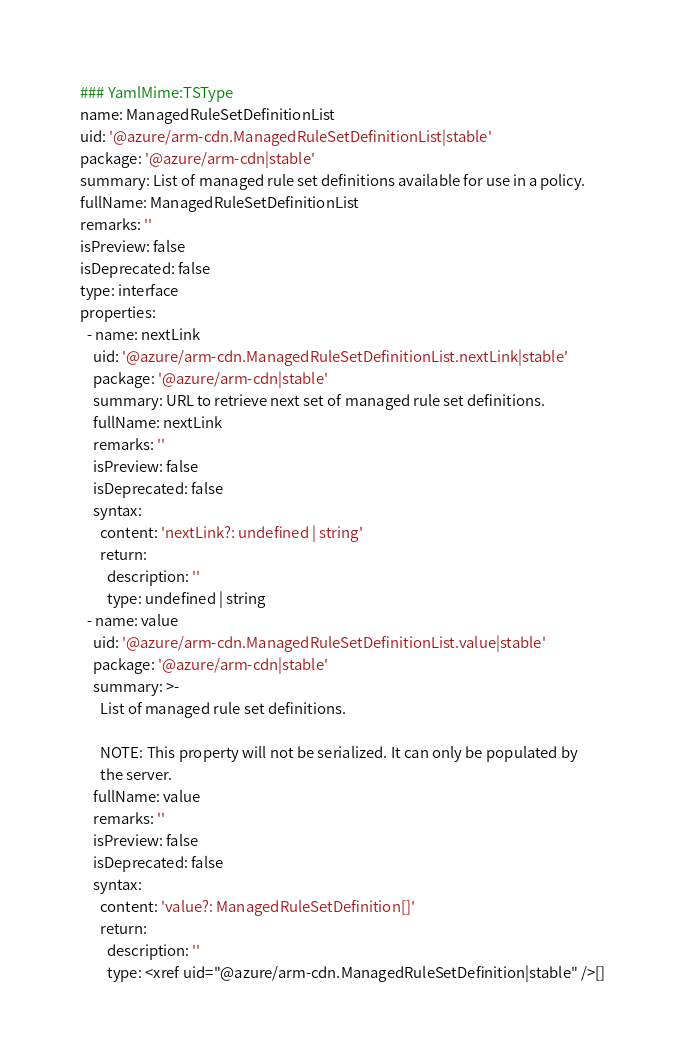Convert code to text. <code><loc_0><loc_0><loc_500><loc_500><_YAML_>### YamlMime:TSType
name: ManagedRuleSetDefinitionList
uid: '@azure/arm-cdn.ManagedRuleSetDefinitionList|stable'
package: '@azure/arm-cdn|stable'
summary: List of managed rule set definitions available for use in a policy.
fullName: ManagedRuleSetDefinitionList
remarks: ''
isPreview: false
isDeprecated: false
type: interface
properties:
  - name: nextLink
    uid: '@azure/arm-cdn.ManagedRuleSetDefinitionList.nextLink|stable'
    package: '@azure/arm-cdn|stable'
    summary: URL to retrieve next set of managed rule set definitions.
    fullName: nextLink
    remarks: ''
    isPreview: false
    isDeprecated: false
    syntax:
      content: 'nextLink?: undefined | string'
      return:
        description: ''
        type: undefined | string
  - name: value
    uid: '@azure/arm-cdn.ManagedRuleSetDefinitionList.value|stable'
    package: '@azure/arm-cdn|stable'
    summary: >-
      List of managed rule set definitions.

      NOTE: This property will not be serialized. It can only be populated by
      the server.
    fullName: value
    remarks: ''
    isPreview: false
    isDeprecated: false
    syntax:
      content: 'value?: ManagedRuleSetDefinition[]'
      return:
        description: ''
        type: <xref uid="@azure/arm-cdn.ManagedRuleSetDefinition|stable" />[]
</code> 